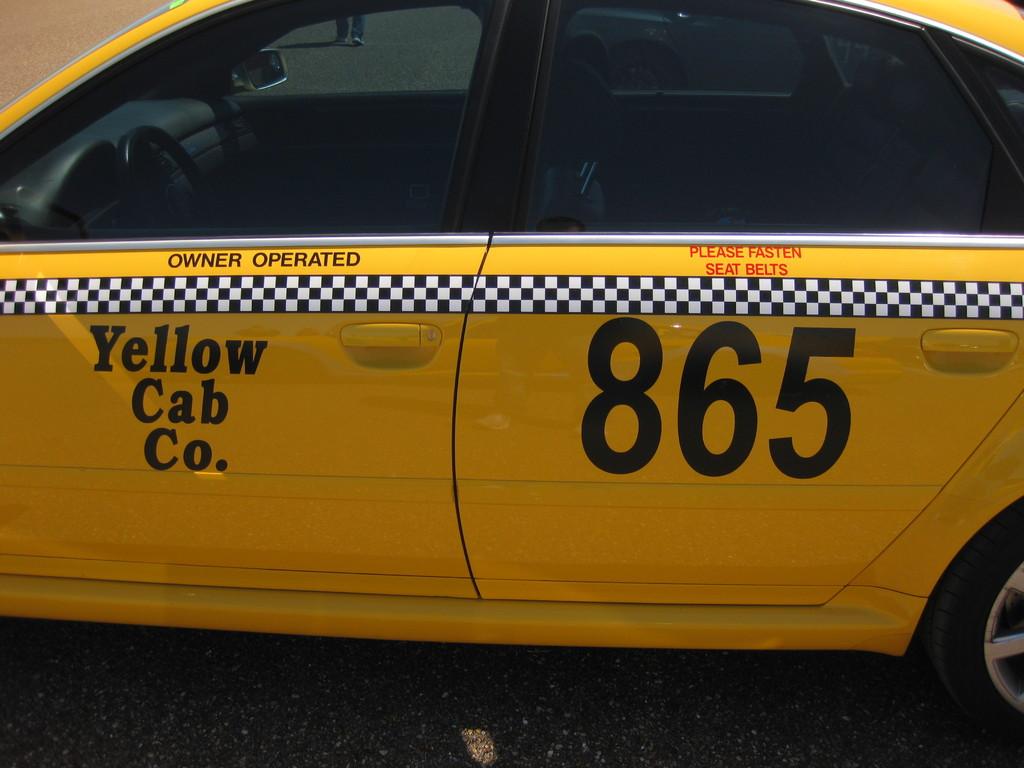What is the number written on the cab?
Ensure brevity in your answer.  865. 